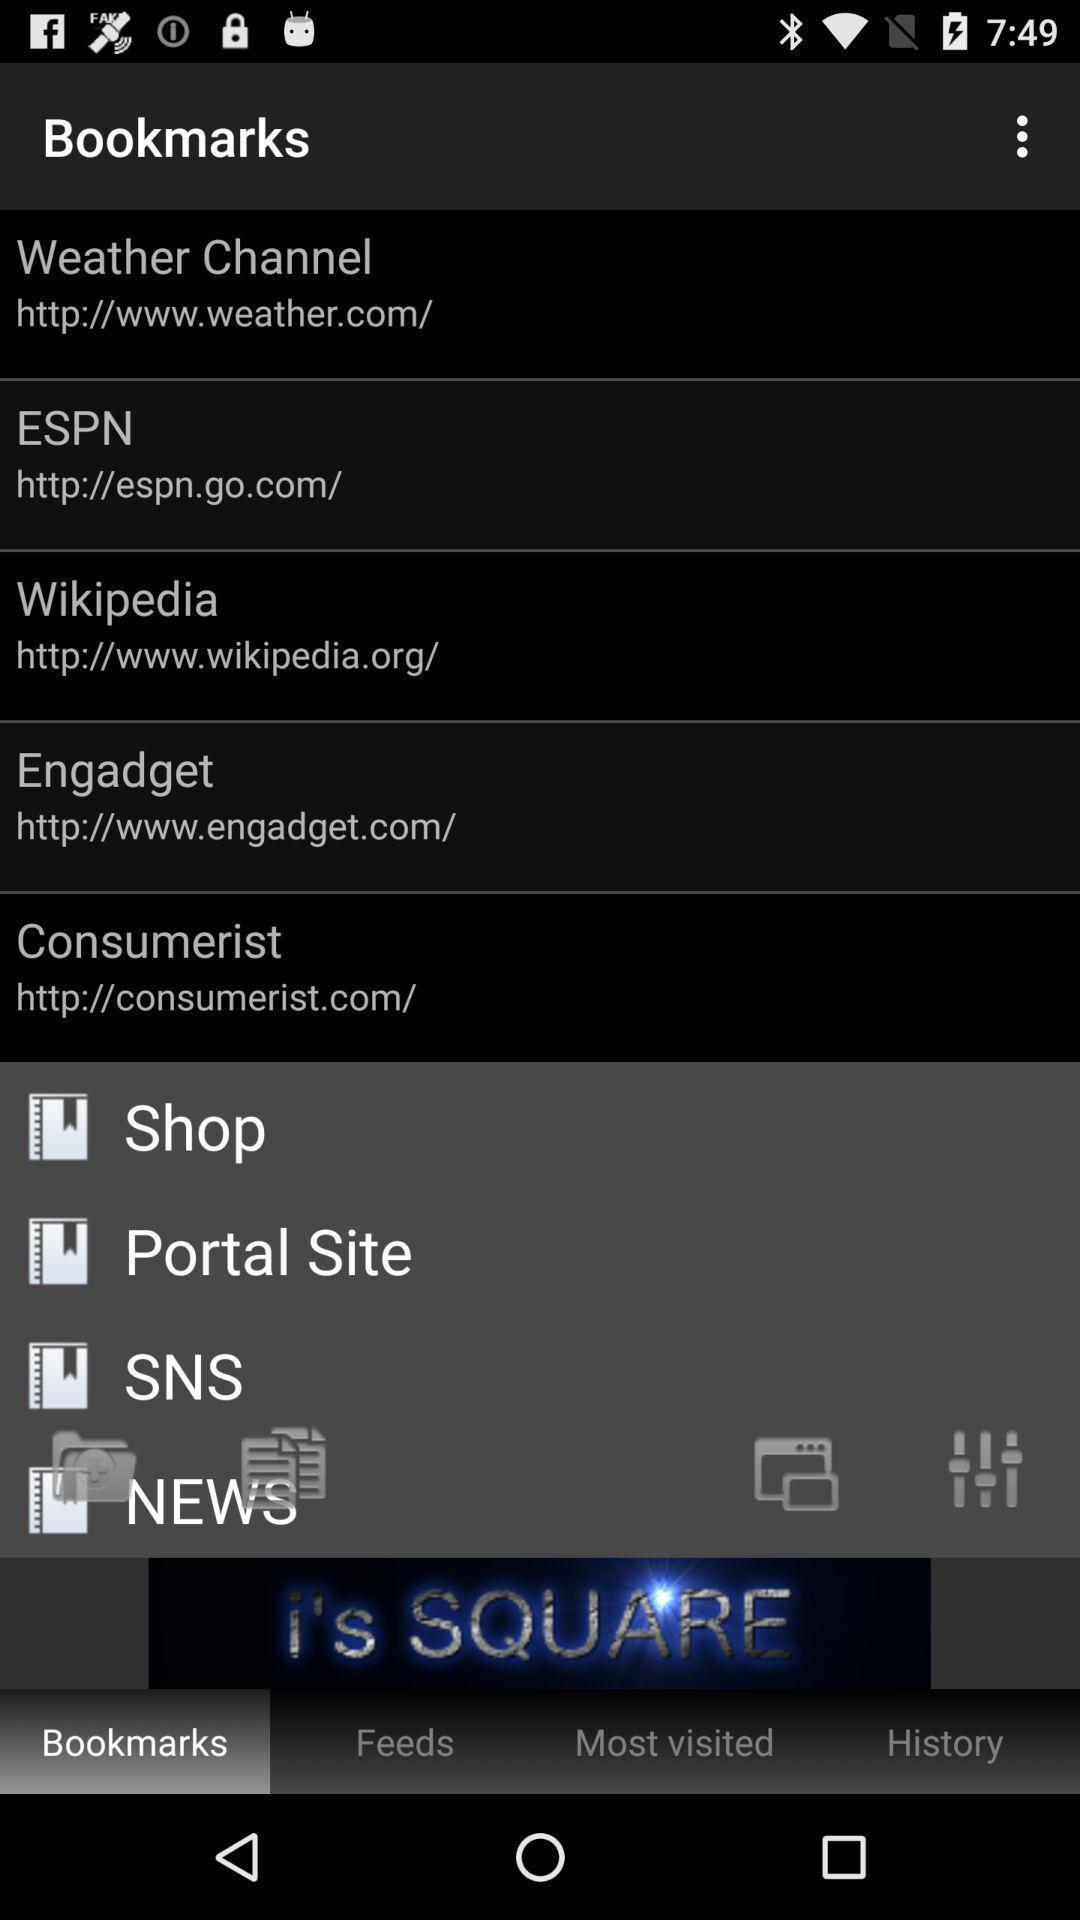How many bookmarks have a website URL in their name?
Answer the question using a single word or phrase. 5 